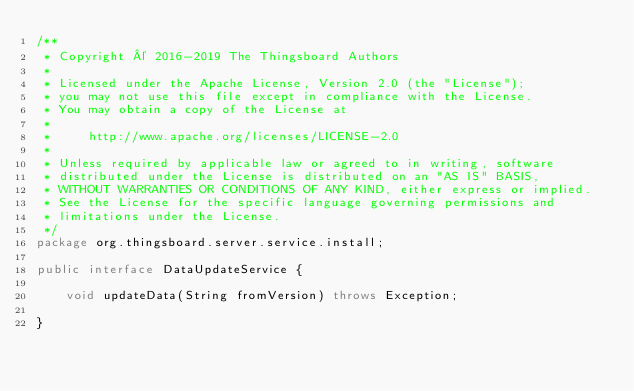<code> <loc_0><loc_0><loc_500><loc_500><_Java_>/**
 * Copyright © 2016-2019 The Thingsboard Authors
 *
 * Licensed under the Apache License, Version 2.0 (the "License");
 * you may not use this file except in compliance with the License.
 * You may obtain a copy of the License at
 *
 *     http://www.apache.org/licenses/LICENSE-2.0
 *
 * Unless required by applicable law or agreed to in writing, software
 * distributed under the License is distributed on an "AS IS" BASIS,
 * WITHOUT WARRANTIES OR CONDITIONS OF ANY KIND, either express or implied.
 * See the License for the specific language governing permissions and
 * limitations under the License.
 */
package org.thingsboard.server.service.install;

public interface DataUpdateService {

    void updateData(String fromVersion) throws Exception;

}
</code> 